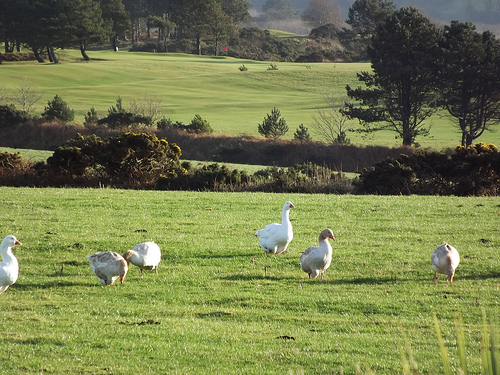<image>
Is the grass on the duck? No. The grass is not positioned on the duck. They may be near each other, but the grass is not supported by or resting on top of the duck. 